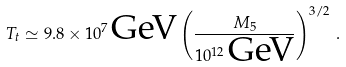<formula> <loc_0><loc_0><loc_500><loc_500>T _ { t } \simeq 9 . 8 \times 1 0 ^ { 7 } \, \text {GeV} \left ( \frac { M _ { 5 } } { 1 0 ^ { 1 2 } \, \text {GeV} } \right ) ^ { 3 / 2 } \, .</formula> 